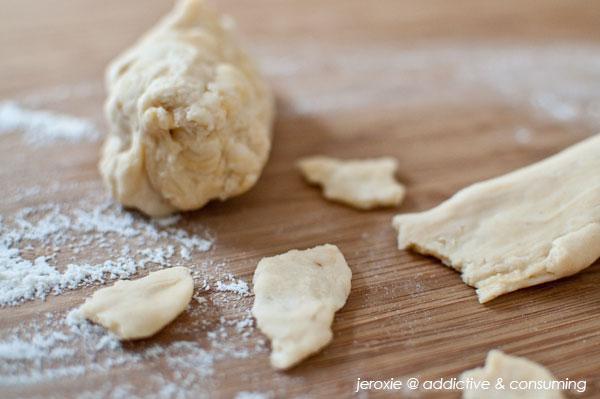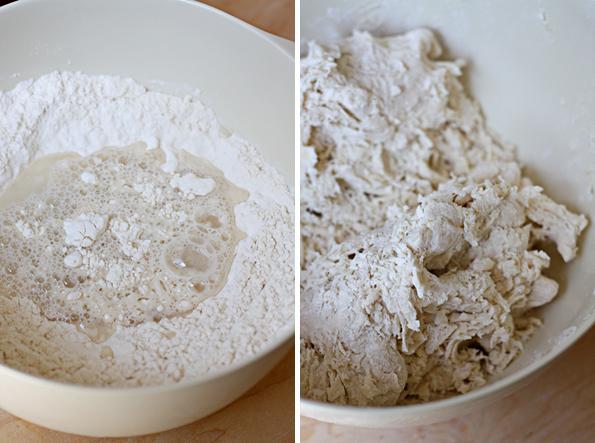The first image is the image on the left, the second image is the image on the right. Considering the images on both sides, is "Dough and flour are on a wooden cutting board." valid? Answer yes or no. Yes. The first image is the image on the left, the second image is the image on the right. Examine the images to the left and right. Is the description "An image contains a human hand touching a mound of dough." accurate? Answer yes or no. No. 